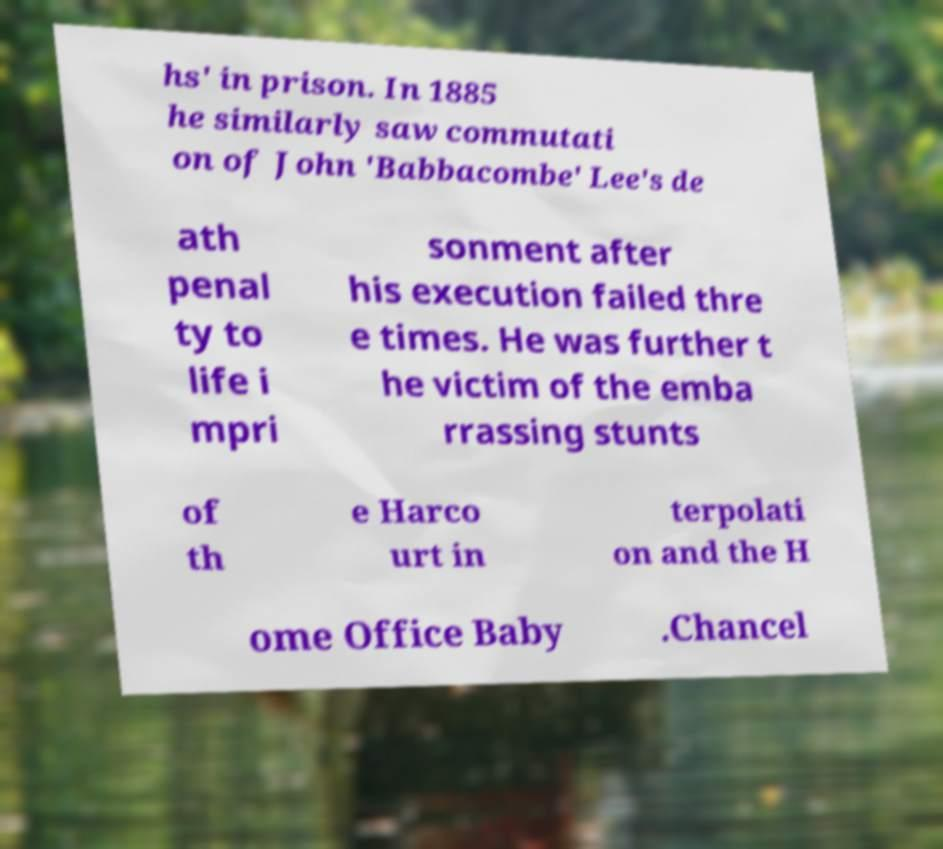Please read and relay the text visible in this image. What does it say? hs' in prison. In 1885 he similarly saw commutati on of John 'Babbacombe' Lee's de ath penal ty to life i mpri sonment after his execution failed thre e times. He was further t he victim of the emba rrassing stunts of th e Harco urt in terpolati on and the H ome Office Baby .Chancel 